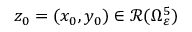<formula> <loc_0><loc_0><loc_500><loc_500>z _ { 0 } = ( x _ { 0 } , y _ { 0 } ) \in \mathcal { R } ( \Omega _ { \varepsilon } ^ { 5 } )</formula> 